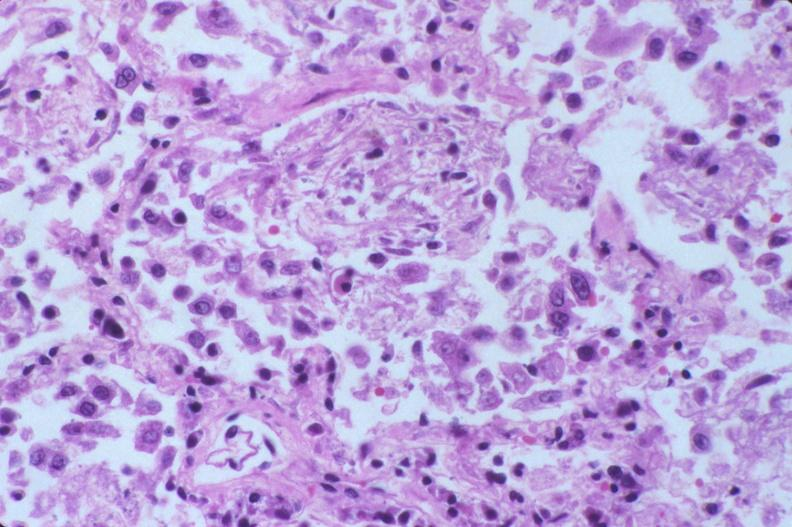what does this image show?
Answer the question using a single word or phrase. Lung 